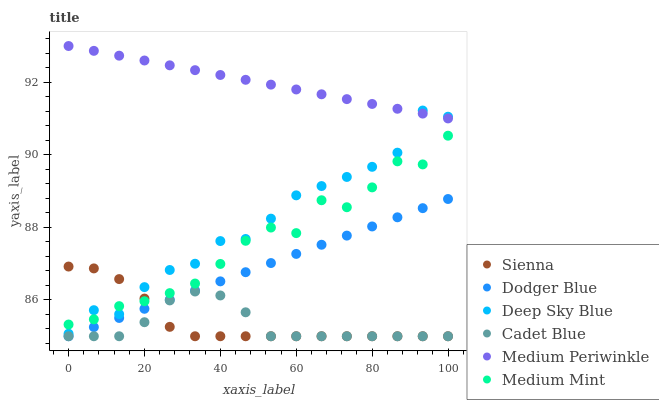Does Cadet Blue have the minimum area under the curve?
Answer yes or no. Yes. Does Medium Periwinkle have the maximum area under the curve?
Answer yes or no. Yes. Does Medium Periwinkle have the minimum area under the curve?
Answer yes or no. No. Does Cadet Blue have the maximum area under the curve?
Answer yes or no. No. Is Medium Periwinkle the smoothest?
Answer yes or no. Yes. Is Medium Mint the roughest?
Answer yes or no. Yes. Is Cadet Blue the smoothest?
Answer yes or no. No. Is Cadet Blue the roughest?
Answer yes or no. No. Does Cadet Blue have the lowest value?
Answer yes or no. Yes. Does Medium Periwinkle have the lowest value?
Answer yes or no. No. Does Medium Periwinkle have the highest value?
Answer yes or no. Yes. Does Cadet Blue have the highest value?
Answer yes or no. No. Is Dodger Blue less than Medium Mint?
Answer yes or no. Yes. Is Medium Mint greater than Cadet Blue?
Answer yes or no. Yes. Does Cadet Blue intersect Sienna?
Answer yes or no. Yes. Is Cadet Blue less than Sienna?
Answer yes or no. No. Is Cadet Blue greater than Sienna?
Answer yes or no. No. Does Dodger Blue intersect Medium Mint?
Answer yes or no. No. 